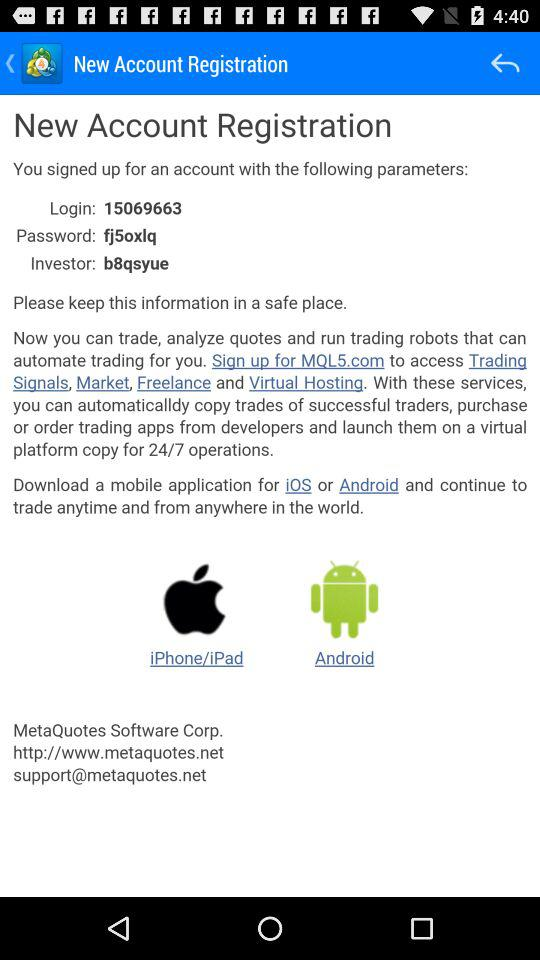On which website can we sign up to access trading signals? The website is MQL5.com. 